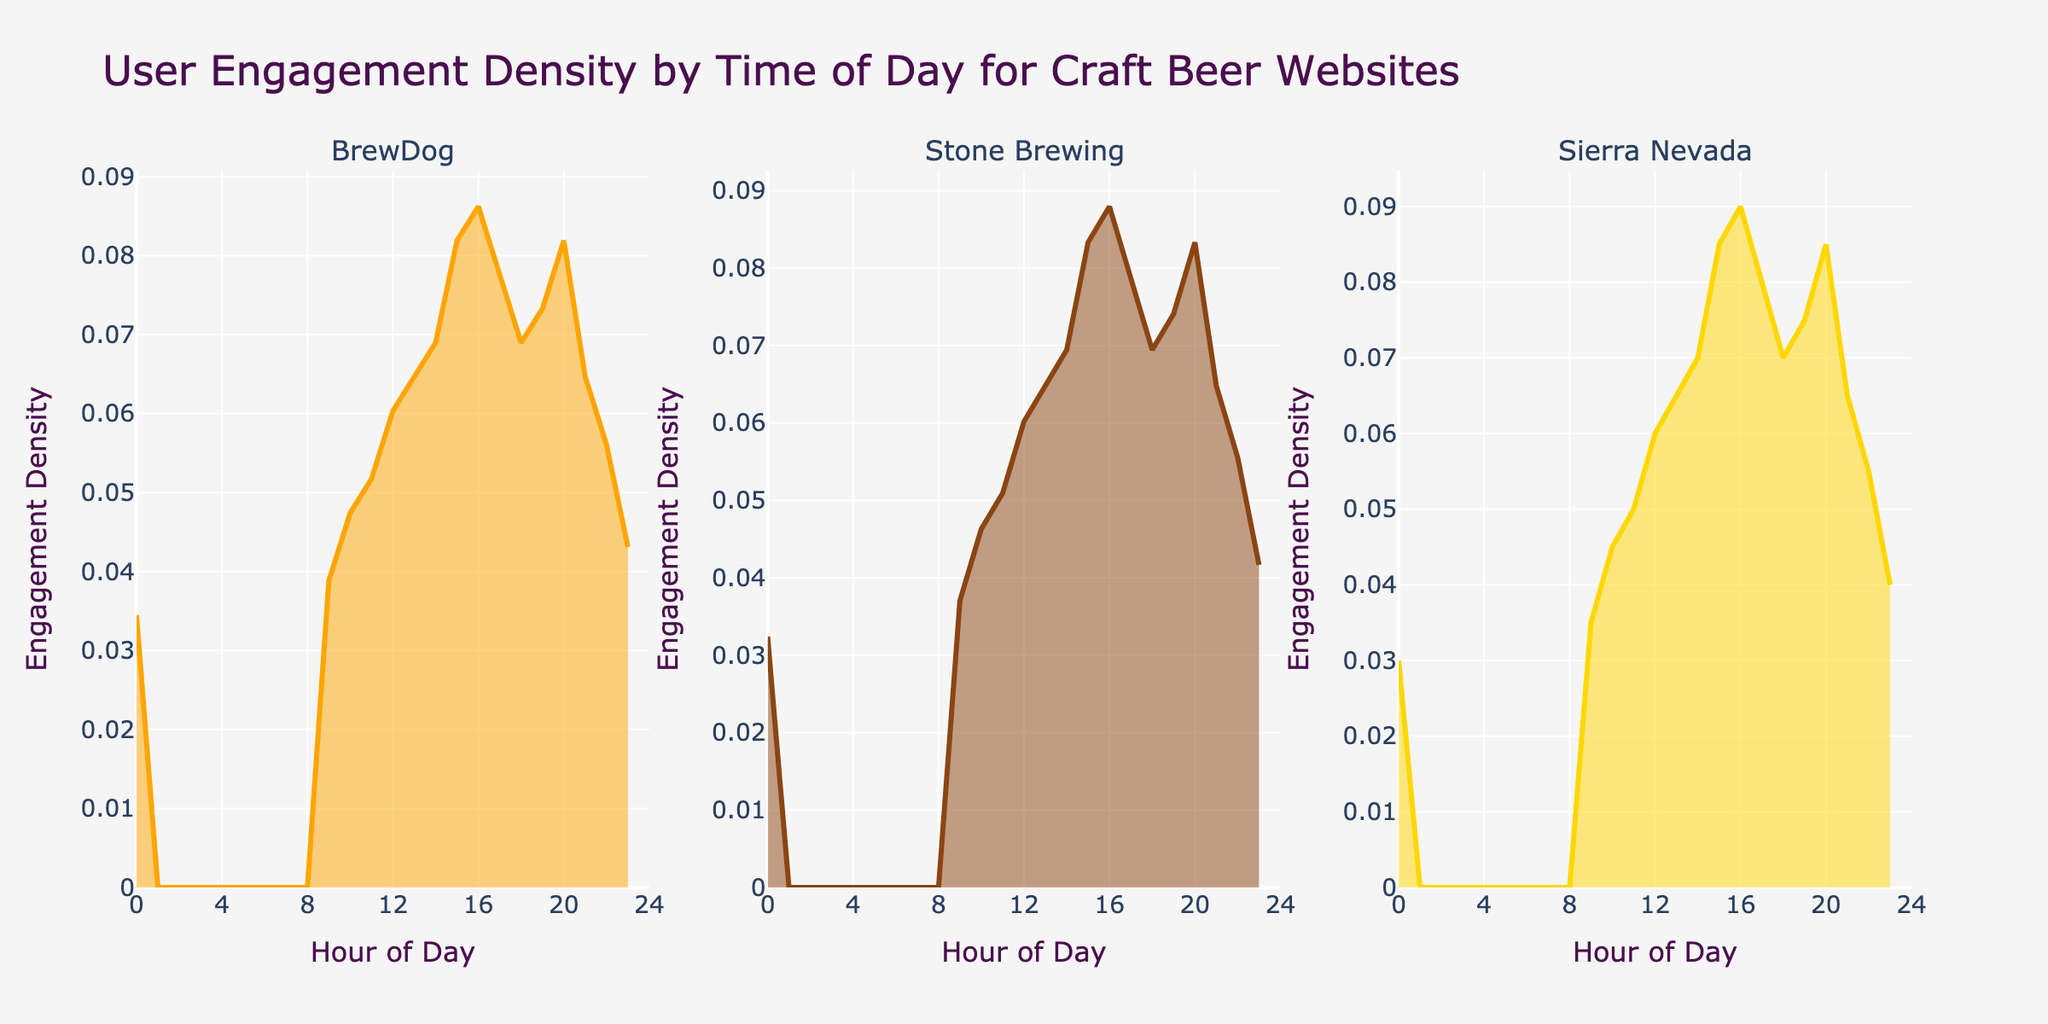What's the title of the figure? The title of the figure is prominently displayed at the top of the plot.
Answer: User Engagement Density by Time of Day for Craft Beer Websites Which website shows the highest engagement density in the evening hours around 20:00? By observing the peak heights around 20:00, BrewDog demonstrates the highest engagement density compared to Stone Brewing and Sierra Nevada.
Answer: BrewDog What is the color used for Sierra Nevada's density plot? Each subplot uses different colors, and Sierra Nevada's density plot is represented in gold.
Answer: Gold At what hour does Stone Brewing reach its highest engagement density? Looking at the plot for Stone Brewing, the peak engagement density is observed around 16:00.
Answer: 16:00 What is the engagement density value for BrewDog at 15:00 compared to 12:00? For BrewDog, at 15:00, the density value is higher than at 12:00, indicating increased engagement in the afternoon.
Answer: Higher at 15:00 Which website has the lowest engagement density early in the morning around 0:00? In the subplot, Sierra Nevada shows the lowest engagement density around 0:00 when compared to BrewDog and Stone Brewing.
Answer: Sierra Nevada Does the engagement density for Stone Brewing show a consistent pattern throughout the day? Stone Brewing's engagement density increases until 16:00, then declines consistently, indicating two peaks: around 16:00 and 20:00, but not throughout the entire day.
Answer: No Comparing BrewDog and Sierra Nevada, which website shows a broader range of engagement density throughout the day? BrewDog's density plot shows more pronounced peaks and valleys spread over various hours compared to Sierra Nevada, suggesting a broader range of engagement throughout the day.
Answer: BrewDog What's the overall trend in user engagement density for all websites in the evening hours? All three websites show increased engagement density during the evening hours, with visible peaks around 20:00 - 21:00.
Answer: Increased 